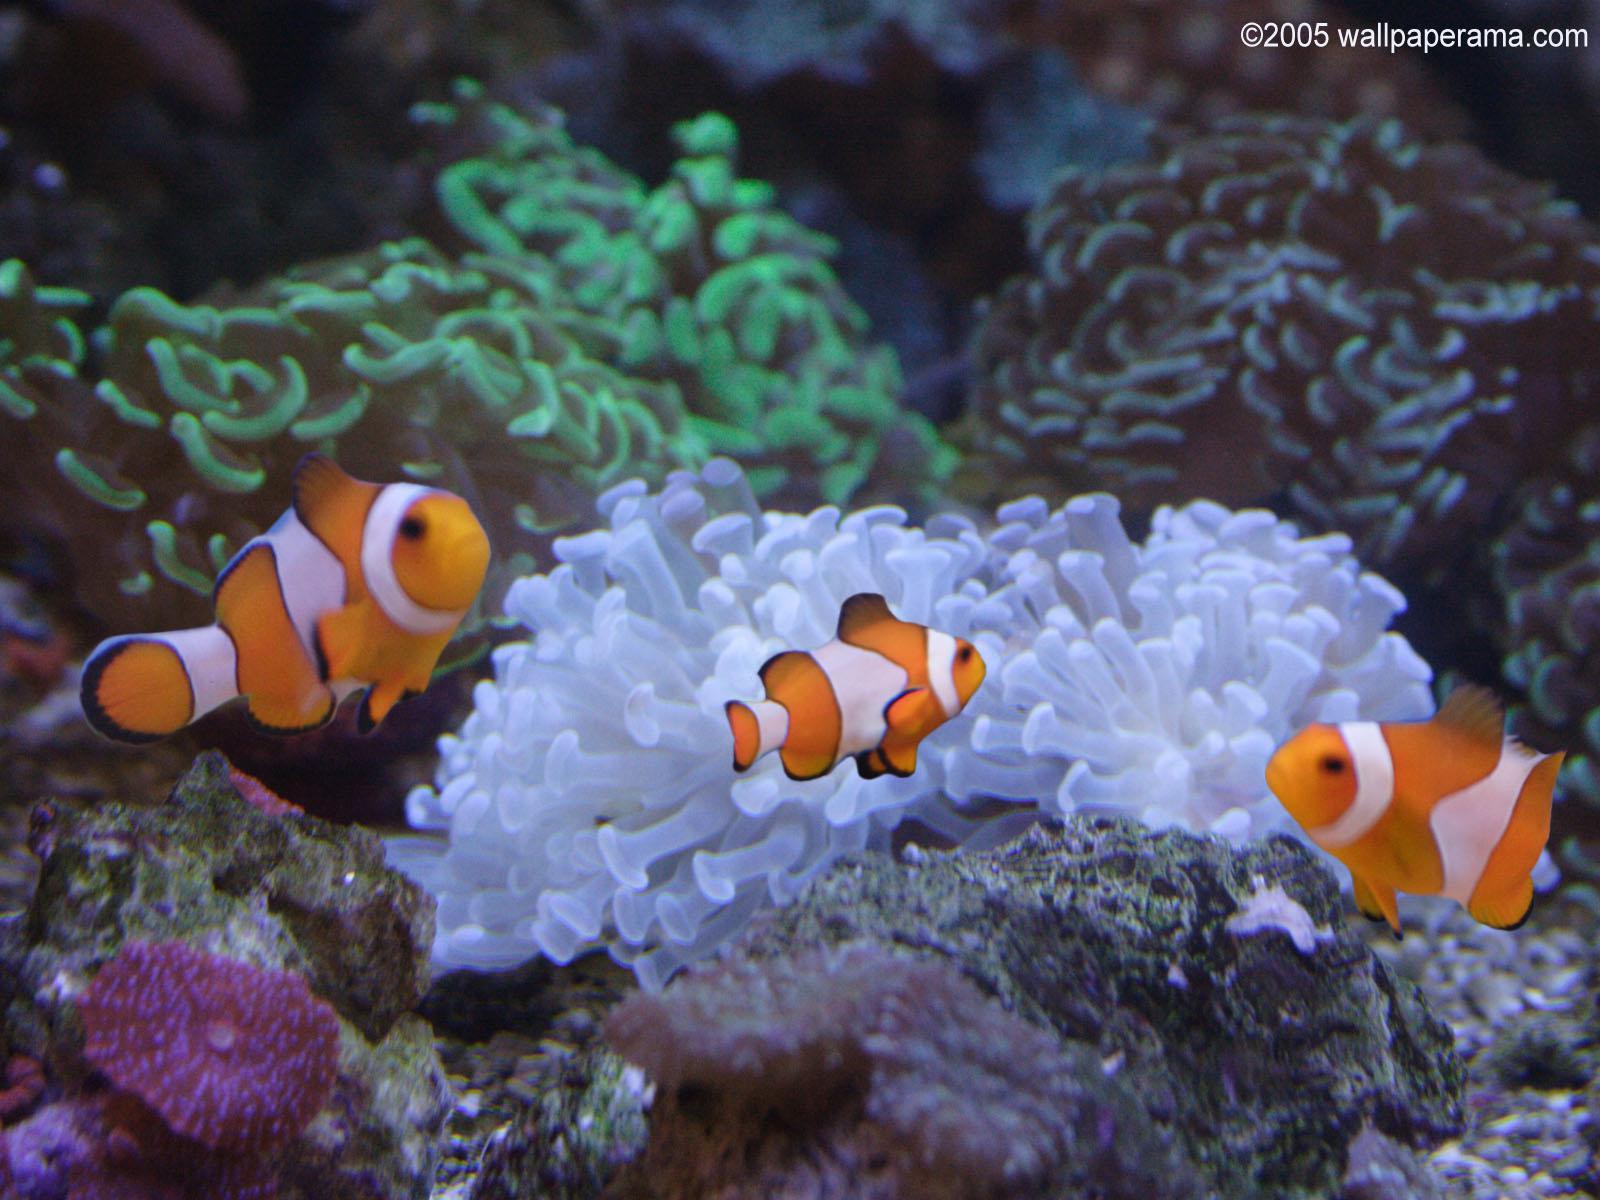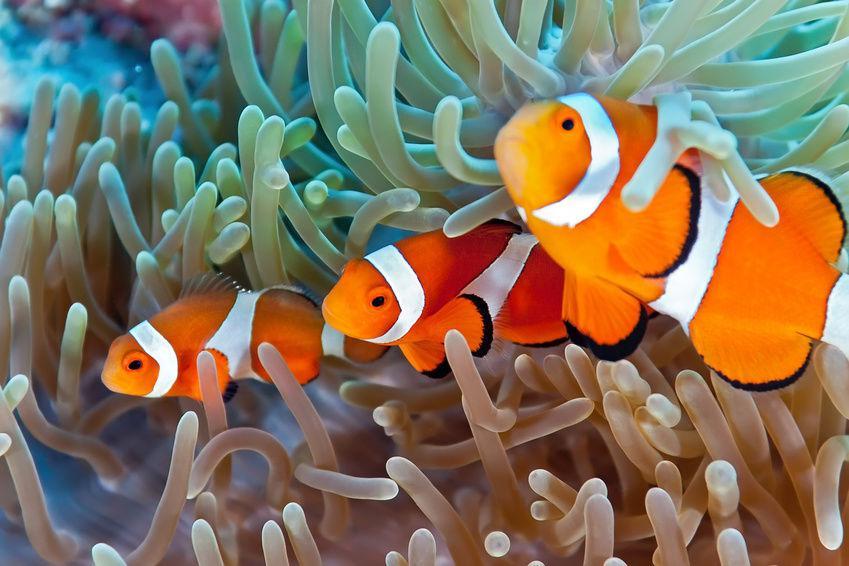The first image is the image on the left, the second image is the image on the right. For the images displayed, is the sentence "Each image features clownfish swimming in front of anemone tendrils, and no image contains more than four clownfish." factually correct? Answer yes or no. Yes. 